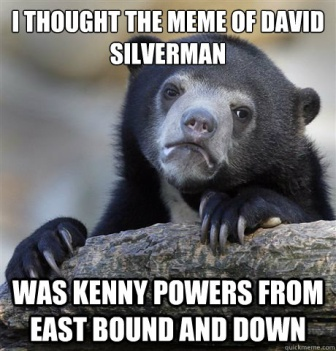What kind of bear is shown in the image? The bear shown in the image is a black bear. These bears are a common species in North America and are known for their adaptability to various habitats. 